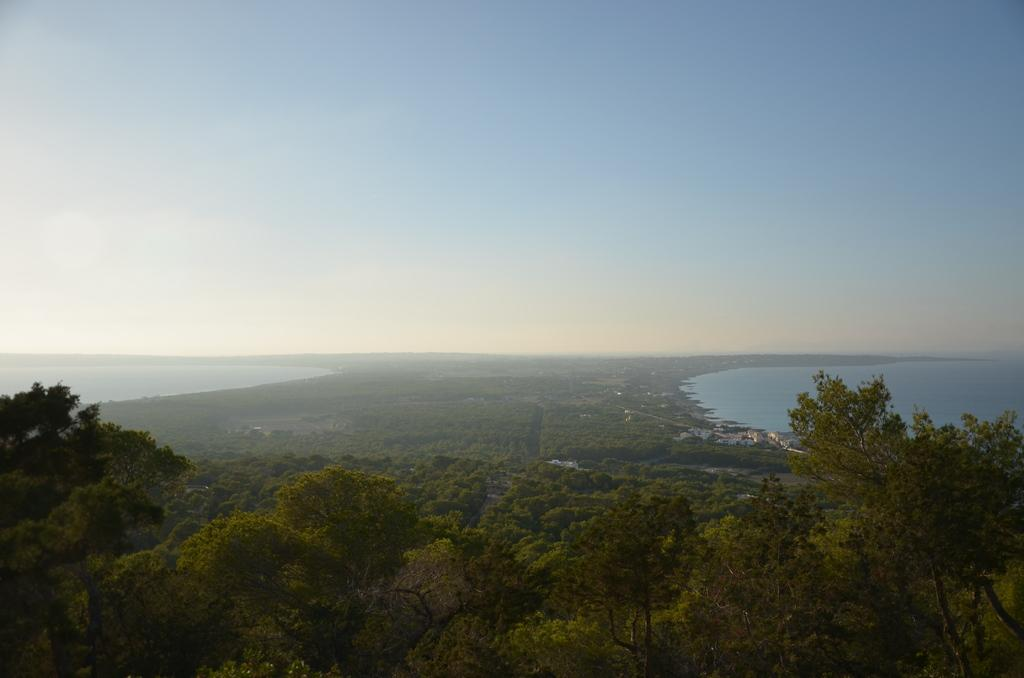What type of vegetation can be seen in the image? There are trees in the image. What natural element is visible in the image? There is water visible in the image. What type of soda is being served at the table in the image? There is no table or soda present in the image; it only features trees and water. What type of furniture can be seen in the image? There is no furniture present in the image; it only features trees and water. 